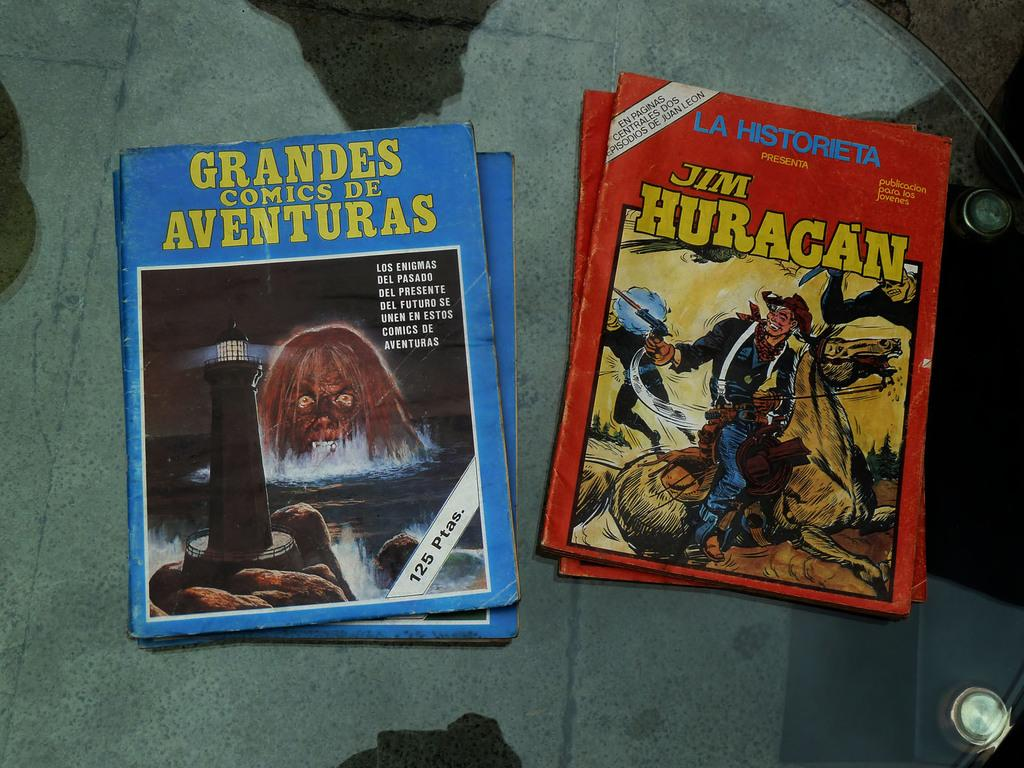How many books are visible in the image? There are four books in the image. Where are the books located? The books are on a glass table. What type of toy is sitting on the shelf in the image? There is no toy or shelf present in the image; it only features four books on a glass table. 